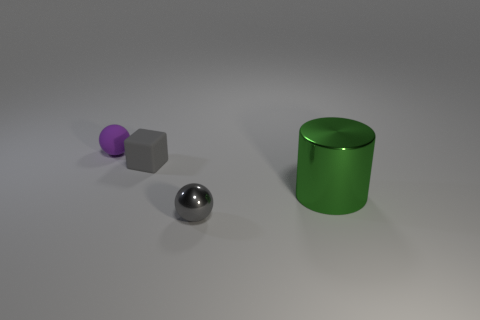There is a matte object that is in front of the ball that is on the left side of the thing that is in front of the cylinder; what is its size?
Provide a short and direct response. Small. How big is the shiny cylinder behind the metal sphere?
Your answer should be compact. Large. How many brown objects are either cylinders or small matte spheres?
Keep it short and to the point. 0. Are there any yellow cylinders that have the same size as the gray cube?
Your answer should be very brief. No. What is the material of the block that is the same size as the purple ball?
Provide a short and direct response. Rubber. There is a rubber object right of the purple rubber thing; is it the same size as the shiny object that is to the left of the large metal cylinder?
Offer a terse response. Yes. What number of things are either tiny objects or shiny things that are to the left of the metal cylinder?
Provide a short and direct response. 3. Is there a purple rubber thing that has the same shape as the tiny metal thing?
Your response must be concise. Yes. What size is the green object right of the tiny sphere on the left side of the small metallic sphere?
Ensure brevity in your answer.  Large. Does the small cube have the same color as the tiny shiny sphere?
Keep it short and to the point. Yes. 